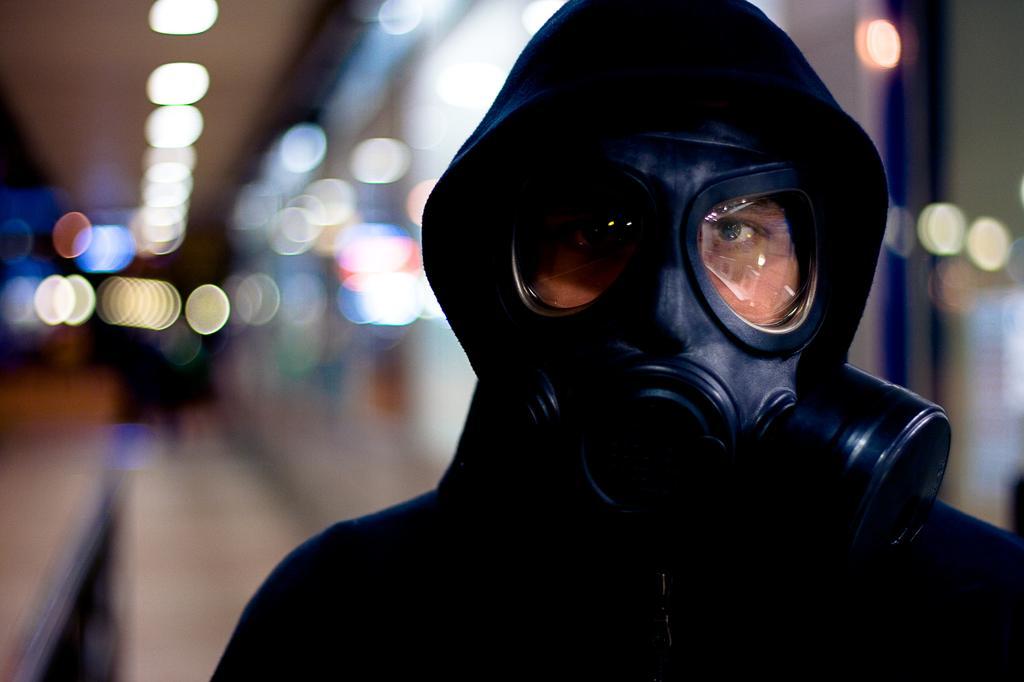Describe this image in one or two sentences. In this picture we can see the person wearing a mask, behind we can see light focus. 